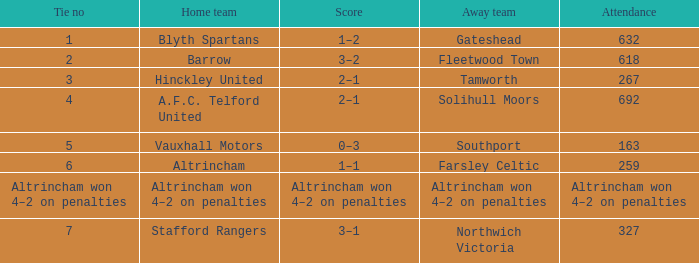Could you help me parse every detail presented in this table? {'header': ['Tie no', 'Home team', 'Score', 'Away team', 'Attendance'], 'rows': [['1', 'Blyth Spartans', '1–2', 'Gateshead', '632'], ['2', 'Barrow', '3–2', 'Fleetwood Town', '618'], ['3', 'Hinckley United', '2–1', 'Tamworth', '267'], ['4', 'A.F.C. Telford United', '2–1', 'Solihull Moors', '692'], ['5', 'Vauxhall Motors', '0–3', 'Southport', '163'], ['6', 'Altrincham', '1–1', 'Farsley Celtic', '259'], ['Altrincham won 4–2 on penalties', 'Altrincham won 4–2 on penalties', 'Altrincham won 4–2 on penalties', 'Altrincham won 4–2 on penalties', 'Altrincham won 4–2 on penalties'], ['7', 'Stafford Rangers', '3–1', 'Northwich Victoria', '327']]} Which domestic team experienced 2 ties? Barrow. 